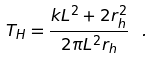<formula> <loc_0><loc_0><loc_500><loc_500>T _ { H } = \frac { k L ^ { 2 } + 2 r _ { h } ^ { 2 } } { 2 \pi L ^ { 2 } r _ { h } } \ .</formula> 